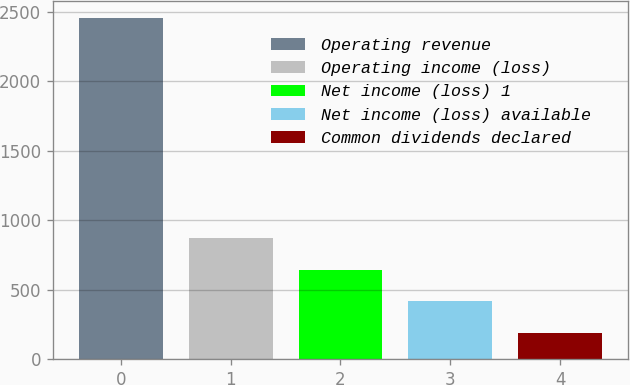Convert chart. <chart><loc_0><loc_0><loc_500><loc_500><bar_chart><fcel>Operating revenue<fcel>Operating income (loss)<fcel>Net income (loss) 1<fcel>Net income (loss) available<fcel>Common dividends declared<nl><fcel>2456<fcel>870.5<fcel>644<fcel>417.5<fcel>191<nl></chart> 